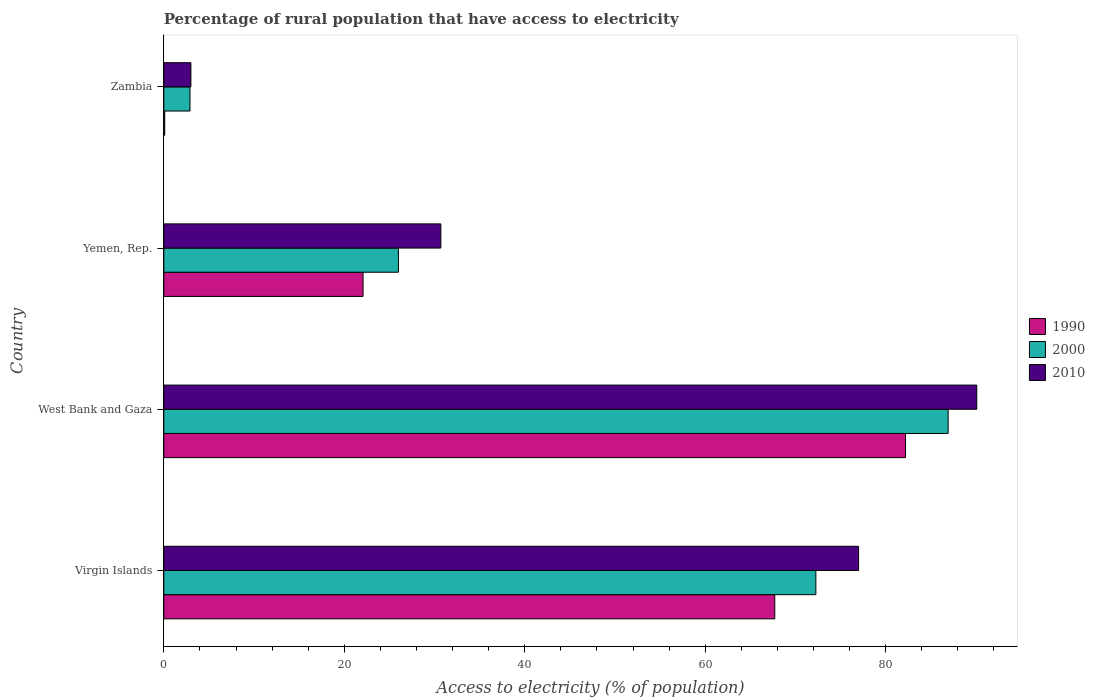How many different coloured bars are there?
Provide a short and direct response. 3. How many groups of bars are there?
Offer a very short reply. 4. Are the number of bars on each tick of the Y-axis equal?
Offer a very short reply. Yes. What is the label of the 3rd group of bars from the top?
Your response must be concise. West Bank and Gaza. In how many cases, is the number of bars for a given country not equal to the number of legend labels?
Ensure brevity in your answer.  0. What is the percentage of rural population that have access to electricity in 1990 in West Bank and Gaza?
Provide a succinct answer. 82.2. Across all countries, what is the maximum percentage of rural population that have access to electricity in 2000?
Keep it short and to the point. 86.93. Across all countries, what is the minimum percentage of rural population that have access to electricity in 1990?
Your answer should be very brief. 0.1. In which country was the percentage of rural population that have access to electricity in 2010 maximum?
Ensure brevity in your answer.  West Bank and Gaza. In which country was the percentage of rural population that have access to electricity in 1990 minimum?
Offer a very short reply. Zambia. What is the total percentage of rural population that have access to electricity in 1990 in the graph?
Keep it short and to the point. 172.09. What is the difference between the percentage of rural population that have access to electricity in 2000 in Virgin Islands and that in West Bank and Gaza?
Make the answer very short. -14.66. What is the difference between the percentage of rural population that have access to electricity in 2010 in Virgin Islands and the percentage of rural population that have access to electricity in 2000 in Zambia?
Your answer should be very brief. 74.1. What is the average percentage of rural population that have access to electricity in 2000 per country?
Your answer should be compact. 47.02. What is the difference between the percentage of rural population that have access to electricity in 1990 and percentage of rural population that have access to electricity in 2010 in Virgin Islands?
Offer a very short reply. -9.29. What is the ratio of the percentage of rural population that have access to electricity in 2010 in Virgin Islands to that in West Bank and Gaza?
Keep it short and to the point. 0.85. Is the percentage of rural population that have access to electricity in 1990 in Virgin Islands less than that in Zambia?
Your answer should be compact. No. What is the difference between the highest and the second highest percentage of rural population that have access to electricity in 2000?
Ensure brevity in your answer.  14.66. What is the difference between the highest and the lowest percentage of rural population that have access to electricity in 2000?
Your response must be concise. 84.03. In how many countries, is the percentage of rural population that have access to electricity in 1990 greater than the average percentage of rural population that have access to electricity in 1990 taken over all countries?
Offer a very short reply. 2. What does the 1st bar from the bottom in Zambia represents?
Your answer should be compact. 1990. Are all the bars in the graph horizontal?
Offer a terse response. Yes. How many countries are there in the graph?
Offer a very short reply. 4. Are the values on the major ticks of X-axis written in scientific E-notation?
Make the answer very short. No. How many legend labels are there?
Make the answer very short. 3. What is the title of the graph?
Provide a succinct answer. Percentage of rural population that have access to electricity. Does "2005" appear as one of the legend labels in the graph?
Ensure brevity in your answer.  No. What is the label or title of the X-axis?
Give a very brief answer. Access to electricity (% of population). What is the label or title of the Y-axis?
Keep it short and to the point. Country. What is the Access to electricity (% of population) in 1990 in Virgin Islands?
Give a very brief answer. 67.71. What is the Access to electricity (% of population) in 2000 in Virgin Islands?
Keep it short and to the point. 72.27. What is the Access to electricity (% of population) of 2010 in Virgin Islands?
Make the answer very short. 77. What is the Access to electricity (% of population) in 1990 in West Bank and Gaza?
Offer a very short reply. 82.2. What is the Access to electricity (% of population) of 2000 in West Bank and Gaza?
Your answer should be compact. 86.93. What is the Access to electricity (% of population) in 2010 in West Bank and Gaza?
Make the answer very short. 90.1. What is the Access to electricity (% of population) in 1990 in Yemen, Rep.?
Your response must be concise. 22.08. What is the Access to electricity (% of population) of 2000 in Yemen, Rep.?
Provide a short and direct response. 26. What is the Access to electricity (% of population) in 2010 in Yemen, Rep.?
Your answer should be compact. 30.7. What is the Access to electricity (% of population) of 2010 in Zambia?
Your response must be concise. 3. Across all countries, what is the maximum Access to electricity (% of population) of 1990?
Keep it short and to the point. 82.2. Across all countries, what is the maximum Access to electricity (% of population) of 2000?
Keep it short and to the point. 86.93. Across all countries, what is the maximum Access to electricity (% of population) in 2010?
Your answer should be very brief. 90.1. Across all countries, what is the minimum Access to electricity (% of population) of 2000?
Ensure brevity in your answer.  2.9. Across all countries, what is the minimum Access to electricity (% of population) of 2010?
Provide a succinct answer. 3. What is the total Access to electricity (% of population) of 1990 in the graph?
Your answer should be compact. 172.09. What is the total Access to electricity (% of population) of 2000 in the graph?
Provide a succinct answer. 188.09. What is the total Access to electricity (% of population) of 2010 in the graph?
Offer a terse response. 200.8. What is the difference between the Access to electricity (% of population) of 1990 in Virgin Islands and that in West Bank and Gaza?
Provide a short and direct response. -14.49. What is the difference between the Access to electricity (% of population) of 2000 in Virgin Islands and that in West Bank and Gaza?
Make the answer very short. -14.66. What is the difference between the Access to electricity (% of population) in 1990 in Virgin Islands and that in Yemen, Rep.?
Keep it short and to the point. 45.63. What is the difference between the Access to electricity (% of population) in 2000 in Virgin Islands and that in Yemen, Rep.?
Provide a succinct answer. 46.27. What is the difference between the Access to electricity (% of population) in 2010 in Virgin Islands and that in Yemen, Rep.?
Your response must be concise. 46.3. What is the difference between the Access to electricity (% of population) of 1990 in Virgin Islands and that in Zambia?
Your response must be concise. 67.61. What is the difference between the Access to electricity (% of population) in 2000 in Virgin Islands and that in Zambia?
Keep it short and to the point. 69.36. What is the difference between the Access to electricity (% of population) in 2010 in Virgin Islands and that in Zambia?
Ensure brevity in your answer.  74. What is the difference between the Access to electricity (% of population) of 1990 in West Bank and Gaza and that in Yemen, Rep.?
Your response must be concise. 60.12. What is the difference between the Access to electricity (% of population) in 2000 in West Bank and Gaza and that in Yemen, Rep.?
Your answer should be compact. 60.93. What is the difference between the Access to electricity (% of population) in 2010 in West Bank and Gaza and that in Yemen, Rep.?
Offer a very short reply. 59.4. What is the difference between the Access to electricity (% of population) in 1990 in West Bank and Gaza and that in Zambia?
Your answer should be very brief. 82.1. What is the difference between the Access to electricity (% of population) in 2000 in West Bank and Gaza and that in Zambia?
Offer a very short reply. 84.03. What is the difference between the Access to electricity (% of population) of 2010 in West Bank and Gaza and that in Zambia?
Your answer should be compact. 87.1. What is the difference between the Access to electricity (% of population) of 1990 in Yemen, Rep. and that in Zambia?
Provide a short and direct response. 21.98. What is the difference between the Access to electricity (% of population) in 2000 in Yemen, Rep. and that in Zambia?
Ensure brevity in your answer.  23.1. What is the difference between the Access to electricity (% of population) in 2010 in Yemen, Rep. and that in Zambia?
Offer a very short reply. 27.7. What is the difference between the Access to electricity (% of population) of 1990 in Virgin Islands and the Access to electricity (% of population) of 2000 in West Bank and Gaza?
Make the answer very short. -19.21. What is the difference between the Access to electricity (% of population) in 1990 in Virgin Islands and the Access to electricity (% of population) in 2010 in West Bank and Gaza?
Your answer should be compact. -22.39. What is the difference between the Access to electricity (% of population) of 2000 in Virgin Islands and the Access to electricity (% of population) of 2010 in West Bank and Gaza?
Your response must be concise. -17.84. What is the difference between the Access to electricity (% of population) of 1990 in Virgin Islands and the Access to electricity (% of population) of 2000 in Yemen, Rep.?
Offer a very short reply. 41.71. What is the difference between the Access to electricity (% of population) of 1990 in Virgin Islands and the Access to electricity (% of population) of 2010 in Yemen, Rep.?
Provide a succinct answer. 37.01. What is the difference between the Access to electricity (% of population) in 2000 in Virgin Islands and the Access to electricity (% of population) in 2010 in Yemen, Rep.?
Make the answer very short. 41.56. What is the difference between the Access to electricity (% of population) of 1990 in Virgin Islands and the Access to electricity (% of population) of 2000 in Zambia?
Keep it short and to the point. 64.81. What is the difference between the Access to electricity (% of population) of 1990 in Virgin Islands and the Access to electricity (% of population) of 2010 in Zambia?
Offer a very short reply. 64.71. What is the difference between the Access to electricity (% of population) in 2000 in Virgin Islands and the Access to electricity (% of population) in 2010 in Zambia?
Your answer should be very brief. 69.27. What is the difference between the Access to electricity (% of population) in 1990 in West Bank and Gaza and the Access to electricity (% of population) in 2000 in Yemen, Rep.?
Ensure brevity in your answer.  56.2. What is the difference between the Access to electricity (% of population) in 1990 in West Bank and Gaza and the Access to electricity (% of population) in 2010 in Yemen, Rep.?
Make the answer very short. 51.5. What is the difference between the Access to electricity (% of population) in 2000 in West Bank and Gaza and the Access to electricity (% of population) in 2010 in Yemen, Rep.?
Your response must be concise. 56.23. What is the difference between the Access to electricity (% of population) in 1990 in West Bank and Gaza and the Access to electricity (% of population) in 2000 in Zambia?
Your answer should be very brief. 79.3. What is the difference between the Access to electricity (% of population) in 1990 in West Bank and Gaza and the Access to electricity (% of population) in 2010 in Zambia?
Provide a short and direct response. 79.2. What is the difference between the Access to electricity (% of population) of 2000 in West Bank and Gaza and the Access to electricity (% of population) of 2010 in Zambia?
Keep it short and to the point. 83.93. What is the difference between the Access to electricity (% of population) of 1990 in Yemen, Rep. and the Access to electricity (% of population) of 2000 in Zambia?
Make the answer very short. 19.18. What is the difference between the Access to electricity (% of population) in 1990 in Yemen, Rep. and the Access to electricity (% of population) in 2010 in Zambia?
Provide a short and direct response. 19.08. What is the difference between the Access to electricity (% of population) of 2000 in Yemen, Rep. and the Access to electricity (% of population) of 2010 in Zambia?
Your response must be concise. 23. What is the average Access to electricity (% of population) of 1990 per country?
Make the answer very short. 43.02. What is the average Access to electricity (% of population) of 2000 per country?
Provide a succinct answer. 47.02. What is the average Access to electricity (% of population) in 2010 per country?
Offer a very short reply. 50.2. What is the difference between the Access to electricity (% of population) of 1990 and Access to electricity (% of population) of 2000 in Virgin Islands?
Your answer should be very brief. -4.55. What is the difference between the Access to electricity (% of population) in 1990 and Access to electricity (% of population) in 2010 in Virgin Islands?
Offer a terse response. -9.29. What is the difference between the Access to electricity (% of population) of 2000 and Access to electricity (% of population) of 2010 in Virgin Islands?
Offer a terse response. -4.74. What is the difference between the Access to electricity (% of population) of 1990 and Access to electricity (% of population) of 2000 in West Bank and Gaza?
Ensure brevity in your answer.  -4.72. What is the difference between the Access to electricity (% of population) of 1990 and Access to electricity (% of population) of 2010 in West Bank and Gaza?
Your answer should be very brief. -7.9. What is the difference between the Access to electricity (% of population) of 2000 and Access to electricity (% of population) of 2010 in West Bank and Gaza?
Your response must be concise. -3.17. What is the difference between the Access to electricity (% of population) in 1990 and Access to electricity (% of population) in 2000 in Yemen, Rep.?
Offer a terse response. -3.92. What is the difference between the Access to electricity (% of population) in 1990 and Access to electricity (% of population) in 2010 in Yemen, Rep.?
Provide a succinct answer. -8.62. What is the difference between the Access to electricity (% of population) of 2000 and Access to electricity (% of population) of 2010 in Yemen, Rep.?
Give a very brief answer. -4.7. What is the difference between the Access to electricity (% of population) of 2000 and Access to electricity (% of population) of 2010 in Zambia?
Ensure brevity in your answer.  -0.1. What is the ratio of the Access to electricity (% of population) in 1990 in Virgin Islands to that in West Bank and Gaza?
Provide a succinct answer. 0.82. What is the ratio of the Access to electricity (% of population) of 2000 in Virgin Islands to that in West Bank and Gaza?
Your answer should be compact. 0.83. What is the ratio of the Access to electricity (% of population) in 2010 in Virgin Islands to that in West Bank and Gaza?
Your response must be concise. 0.85. What is the ratio of the Access to electricity (% of population) of 1990 in Virgin Islands to that in Yemen, Rep.?
Your response must be concise. 3.07. What is the ratio of the Access to electricity (% of population) in 2000 in Virgin Islands to that in Yemen, Rep.?
Provide a short and direct response. 2.78. What is the ratio of the Access to electricity (% of population) of 2010 in Virgin Islands to that in Yemen, Rep.?
Give a very brief answer. 2.51. What is the ratio of the Access to electricity (% of population) in 1990 in Virgin Islands to that in Zambia?
Your response must be concise. 677.11. What is the ratio of the Access to electricity (% of population) of 2000 in Virgin Islands to that in Zambia?
Provide a short and direct response. 24.92. What is the ratio of the Access to electricity (% of population) of 2010 in Virgin Islands to that in Zambia?
Your answer should be compact. 25.67. What is the ratio of the Access to electricity (% of population) of 1990 in West Bank and Gaza to that in Yemen, Rep.?
Your answer should be very brief. 3.72. What is the ratio of the Access to electricity (% of population) in 2000 in West Bank and Gaza to that in Yemen, Rep.?
Keep it short and to the point. 3.34. What is the ratio of the Access to electricity (% of population) in 2010 in West Bank and Gaza to that in Yemen, Rep.?
Offer a very short reply. 2.93. What is the ratio of the Access to electricity (% of population) in 1990 in West Bank and Gaza to that in Zambia?
Your response must be concise. 822.03. What is the ratio of the Access to electricity (% of population) in 2000 in West Bank and Gaza to that in Zambia?
Keep it short and to the point. 29.97. What is the ratio of the Access to electricity (% of population) of 2010 in West Bank and Gaza to that in Zambia?
Give a very brief answer. 30.03. What is the ratio of the Access to electricity (% of population) in 1990 in Yemen, Rep. to that in Zambia?
Your answer should be compact. 220.79. What is the ratio of the Access to electricity (% of population) in 2000 in Yemen, Rep. to that in Zambia?
Keep it short and to the point. 8.97. What is the ratio of the Access to electricity (% of population) of 2010 in Yemen, Rep. to that in Zambia?
Provide a short and direct response. 10.23. What is the difference between the highest and the second highest Access to electricity (% of population) in 1990?
Keep it short and to the point. 14.49. What is the difference between the highest and the second highest Access to electricity (% of population) in 2000?
Your answer should be compact. 14.66. What is the difference between the highest and the second highest Access to electricity (% of population) in 2010?
Provide a short and direct response. 13.1. What is the difference between the highest and the lowest Access to electricity (% of population) in 1990?
Offer a very short reply. 82.1. What is the difference between the highest and the lowest Access to electricity (% of population) in 2000?
Make the answer very short. 84.03. What is the difference between the highest and the lowest Access to electricity (% of population) of 2010?
Ensure brevity in your answer.  87.1. 